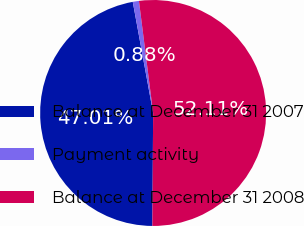<chart> <loc_0><loc_0><loc_500><loc_500><pie_chart><fcel>Balance at December 31 2007<fcel>Payment activity<fcel>Balance at December 31 2008<nl><fcel>47.01%<fcel>0.88%<fcel>52.11%<nl></chart> 